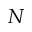Convert formula to latex. <formula><loc_0><loc_0><loc_500><loc_500>N</formula> 